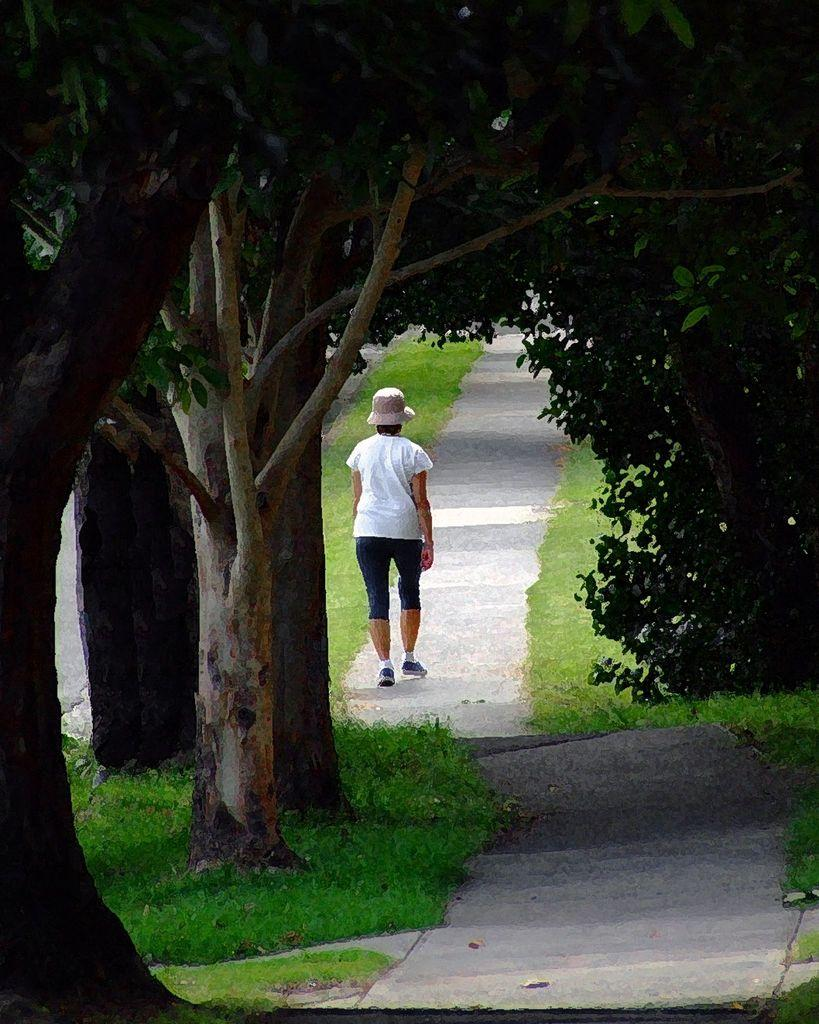Who is present in the image? There is a person in the image. What is the person wearing? The person is wearing clothes. What is the person doing in the image? The person is walking on a path. What can be seen in the background of the image? There are trees visible behind the person. How many boys are smashing shoes in the image? There are no boys or shoes being smashed in the image; it features a person walking on a path with trees in the background. 